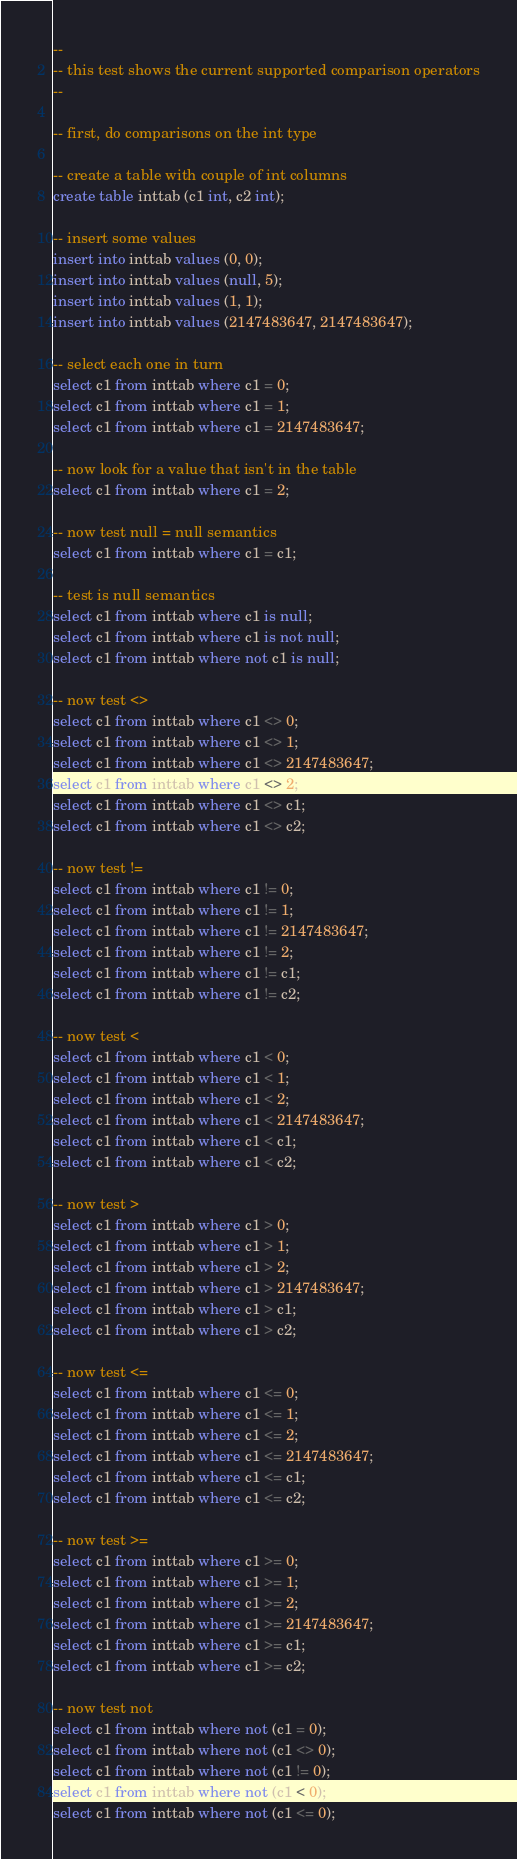Convert code to text. <code><loc_0><loc_0><loc_500><loc_500><_SQL_>--
-- this test shows the current supported comparison operators
--

-- first, do comparisons on the int type

-- create a table with couple of int columns
create table inttab (c1 int, c2 int);

-- insert some values
insert into inttab values (0, 0);
insert into inttab values (null, 5);
insert into inttab values (1, 1);
insert into inttab values (2147483647, 2147483647);

-- select each one in turn
select c1 from inttab where c1 = 0;
select c1 from inttab where c1 = 1;
select c1 from inttab where c1 = 2147483647;

-- now look for a value that isn't in the table
select c1 from inttab where c1 = 2;

-- now test null = null semantics
select c1 from inttab where c1 = c1;

-- test is null semantics
select c1 from inttab where c1 is null;
select c1 from inttab where c1 is not null;
select c1 from inttab where not c1 is null;

-- now test <>
select c1 from inttab where c1 <> 0;
select c1 from inttab where c1 <> 1;
select c1 from inttab where c1 <> 2147483647;
select c1 from inttab where c1 <> 2;
select c1 from inttab where c1 <> c1;
select c1 from inttab where c1 <> c2;

-- now test !=
select c1 from inttab where c1 != 0;
select c1 from inttab where c1 != 1;
select c1 from inttab where c1 != 2147483647;
select c1 from inttab where c1 != 2;
select c1 from inttab where c1 != c1;
select c1 from inttab where c1 != c2;

-- now test <
select c1 from inttab where c1 < 0;
select c1 from inttab where c1 < 1;
select c1 from inttab where c1 < 2;
select c1 from inttab where c1 < 2147483647;
select c1 from inttab where c1 < c1;
select c1 from inttab where c1 < c2;

-- now test >
select c1 from inttab where c1 > 0;
select c1 from inttab where c1 > 1;
select c1 from inttab where c1 > 2;
select c1 from inttab where c1 > 2147483647;
select c1 from inttab where c1 > c1;
select c1 from inttab where c1 > c2;

-- now test <=
select c1 from inttab where c1 <= 0;
select c1 from inttab where c1 <= 1;
select c1 from inttab where c1 <= 2;
select c1 from inttab where c1 <= 2147483647;
select c1 from inttab where c1 <= c1;
select c1 from inttab where c1 <= c2;

-- now test >=
select c1 from inttab where c1 >= 0;
select c1 from inttab where c1 >= 1;
select c1 from inttab where c1 >= 2;
select c1 from inttab where c1 >= 2147483647;
select c1 from inttab where c1 >= c1;
select c1 from inttab where c1 >= c2;

-- now test not
select c1 from inttab where not (c1 = 0);
select c1 from inttab where not (c1 <> 0);
select c1 from inttab where not (c1 != 0);
select c1 from inttab where not (c1 < 0);
select c1 from inttab where not (c1 <= 0);</code> 